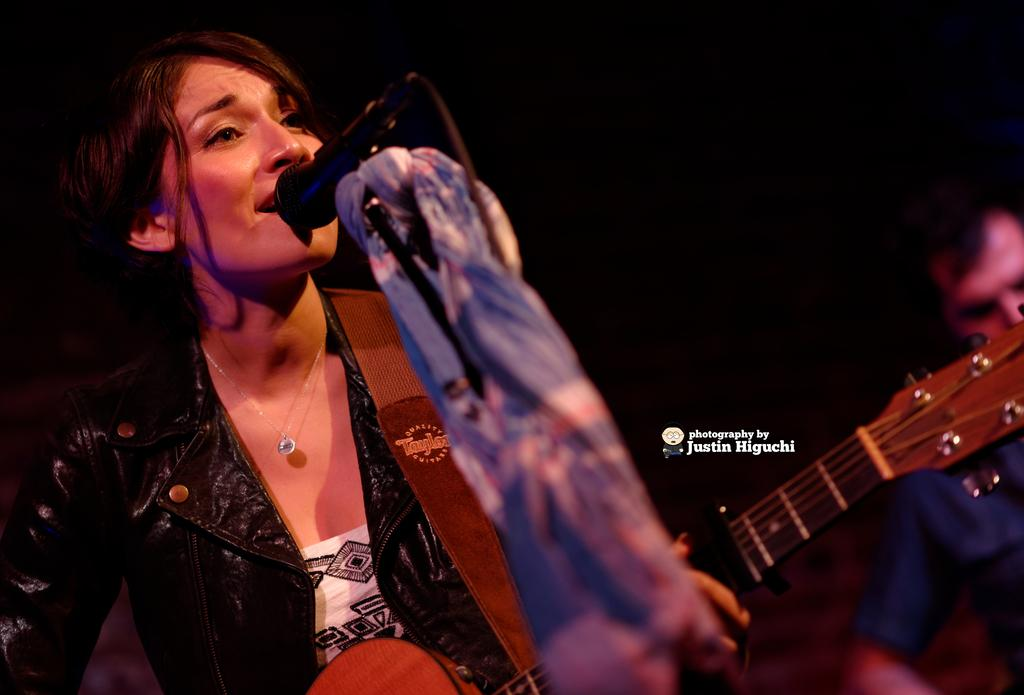Who is the main subject in the image? There is a woman in the image. What is the woman wearing? The woman is wearing a black jacket. What is the woman doing in the image? The woman is singing a song. What object is the woman using while singing? The woman is in front of a microphone. What instrument is the woman holding? The woman is holding a guitar. What type of hat is the woman wearing in the image? There is no hat visible in the image; the woman is wearing a black jacket. 